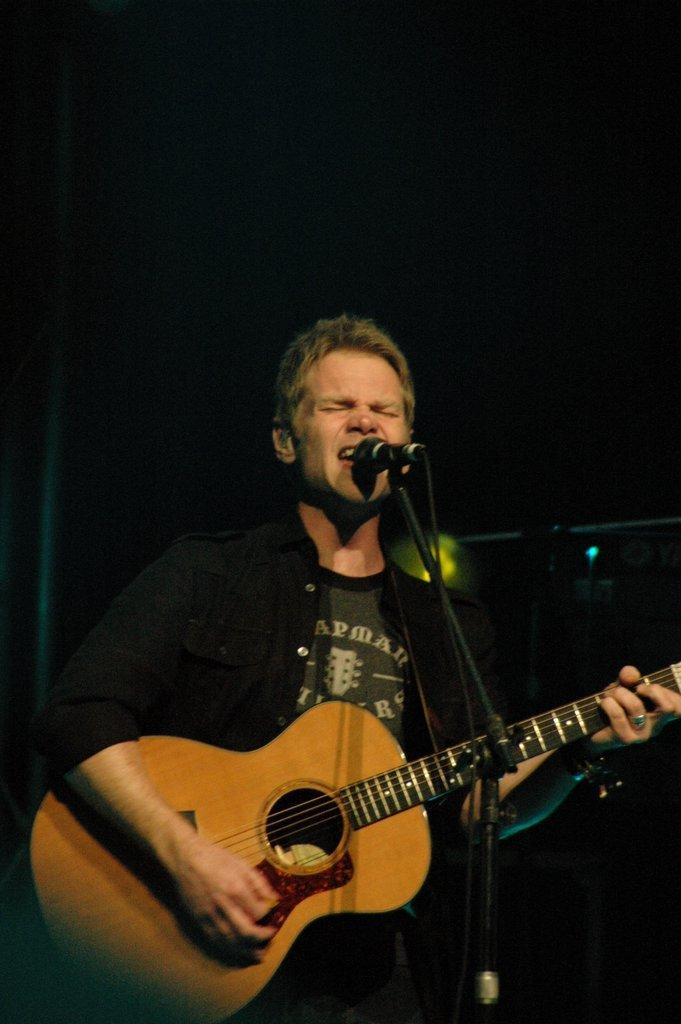What is the man wearing in the image? The man is wearing a black shirt in the image. What is the man doing while wearing the black shirt? The man is playing a guitar and singing in the image. Where is the man positioned in relation to the microphone? The man is in front of a microphone in the image. What is the man's facial expression while singing? The man has his eyes closed in the image. What type of mine is the man operating in the image? There is no mine present in the image; it features a man playing a guitar, singing, and standing in front of a microphone. 